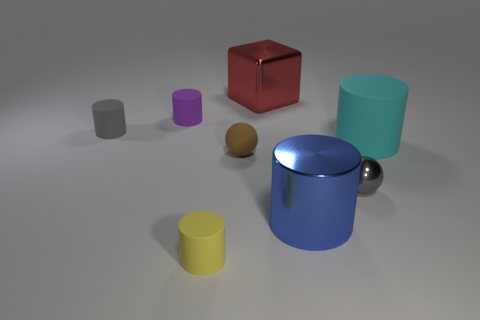Subtract all metal cylinders. How many cylinders are left? 4 Subtract all cyan cylinders. How many cylinders are left? 4 Add 2 yellow things. How many objects exist? 10 Subtract all green cylinders. Subtract all red cubes. How many cylinders are left? 5 Subtract all cubes. How many objects are left? 7 Subtract 1 cyan cylinders. How many objects are left? 7 Subtract all small gray rubber cylinders. Subtract all gray shiny things. How many objects are left? 6 Add 3 brown balls. How many brown balls are left? 4 Add 5 green cubes. How many green cubes exist? 5 